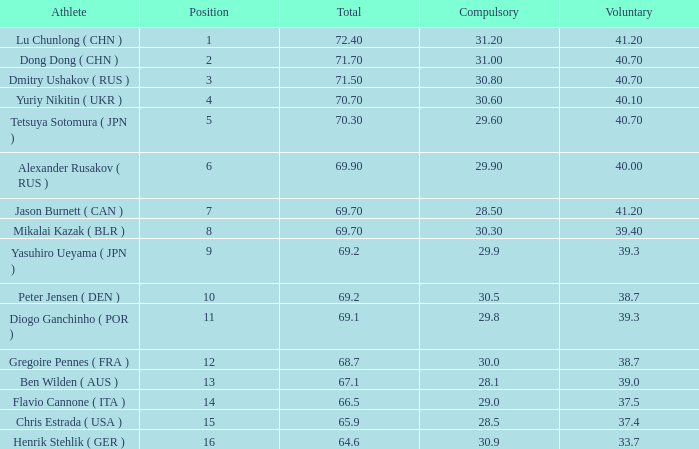What's the position that has a total less than 66.5m, a compulsory of 30.9 and voluntary less than 33.7? None. 